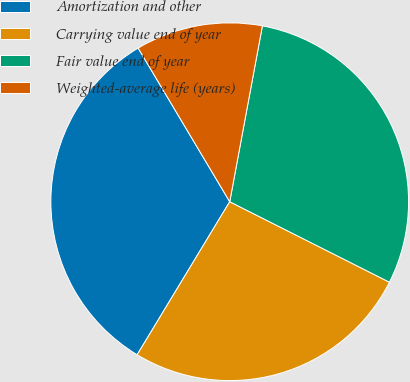<chart> <loc_0><loc_0><loc_500><loc_500><pie_chart><fcel>Amortization and other<fcel>Carrying value end of year<fcel>Fair value end of year<fcel>Weighted-average life (years)<nl><fcel>32.79%<fcel>26.23%<fcel>29.51%<fcel>11.48%<nl></chart> 